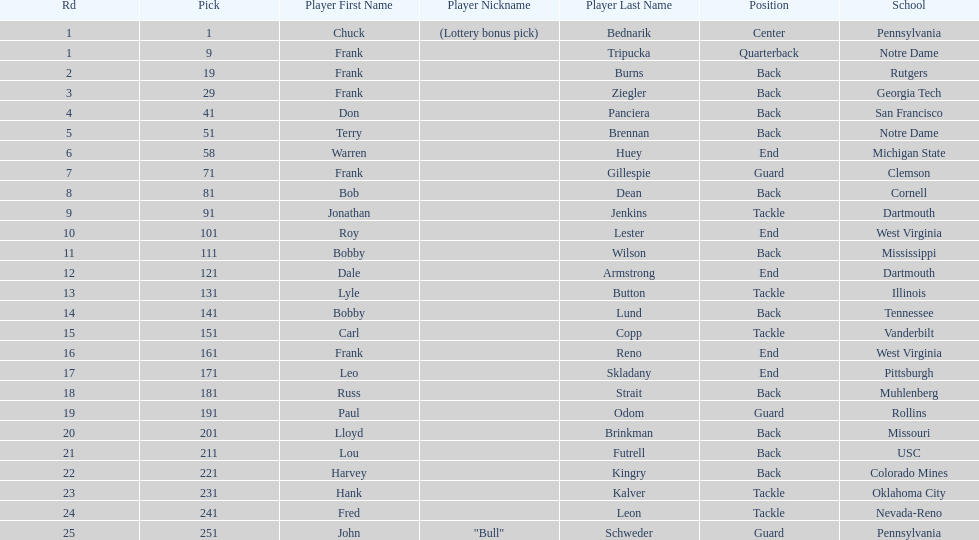Could you parse the entire table as a dict? {'header': ['Rd', 'Pick', 'Player First Name', 'Player Nickname', 'Player Last Name', 'Position', 'School'], 'rows': [['1', '1', 'Chuck', '(Lottery bonus pick)', 'Bednarik', 'Center', 'Pennsylvania'], ['1', '9', 'Frank', '', 'Tripucka', 'Quarterback', 'Notre Dame'], ['2', '19', 'Frank', '', 'Burns', 'Back', 'Rutgers'], ['3', '29', 'Frank', '', 'Ziegler', 'Back', 'Georgia Tech'], ['4', '41', 'Don', '', 'Panciera', 'Back', 'San Francisco'], ['5', '51', 'Terry', '', 'Brennan', 'Back', 'Notre Dame'], ['6', '58', 'Warren', '', 'Huey', 'End', 'Michigan State'], ['7', '71', 'Frank', '', 'Gillespie', 'Guard', 'Clemson'], ['8', '81', 'Bob', '', 'Dean', 'Back', 'Cornell'], ['9', '91', 'Jonathan', '', 'Jenkins', 'Tackle', 'Dartmouth'], ['10', '101', 'Roy', '', 'Lester', 'End', 'West Virginia'], ['11', '111', 'Bobby', '', 'Wilson', 'Back', 'Mississippi'], ['12', '121', 'Dale', '', 'Armstrong', 'End', 'Dartmouth'], ['13', '131', 'Lyle', '', 'Button', 'Tackle', 'Illinois'], ['14', '141', 'Bobby', '', 'Lund', 'Back', 'Tennessee'], ['15', '151', 'Carl', '', 'Copp', 'Tackle', 'Vanderbilt'], ['16', '161', 'Frank', '', 'Reno', 'End', 'West Virginia'], ['17', '171', 'Leo', '', 'Skladany', 'End', 'Pittsburgh'], ['18', '181', 'Russ', '', 'Strait', 'Back', 'Muhlenberg'], ['19', '191', 'Paul', '', 'Odom', 'Guard', 'Rollins'], ['20', '201', 'Lloyd', '', 'Brinkman', 'Back', 'Missouri'], ['21', '211', 'Lou', '', 'Futrell', 'Back', 'USC'], ['22', '221', 'Harvey', '', 'Kingry', 'Back', 'Colorado Mines'], ['23', '231', 'Hank', '', 'Kalver', 'Tackle', 'Oklahoma City'], ['24', '241', 'Fred', '', 'Leon', 'Tackle', 'Nevada-Reno'], ['25', '251', 'John', '"Bull"', 'Schweder', 'Guard', 'Pennsylvania']]} Who has same position as frank gillespie? Paul Odom, John "Bull" Schweder. 